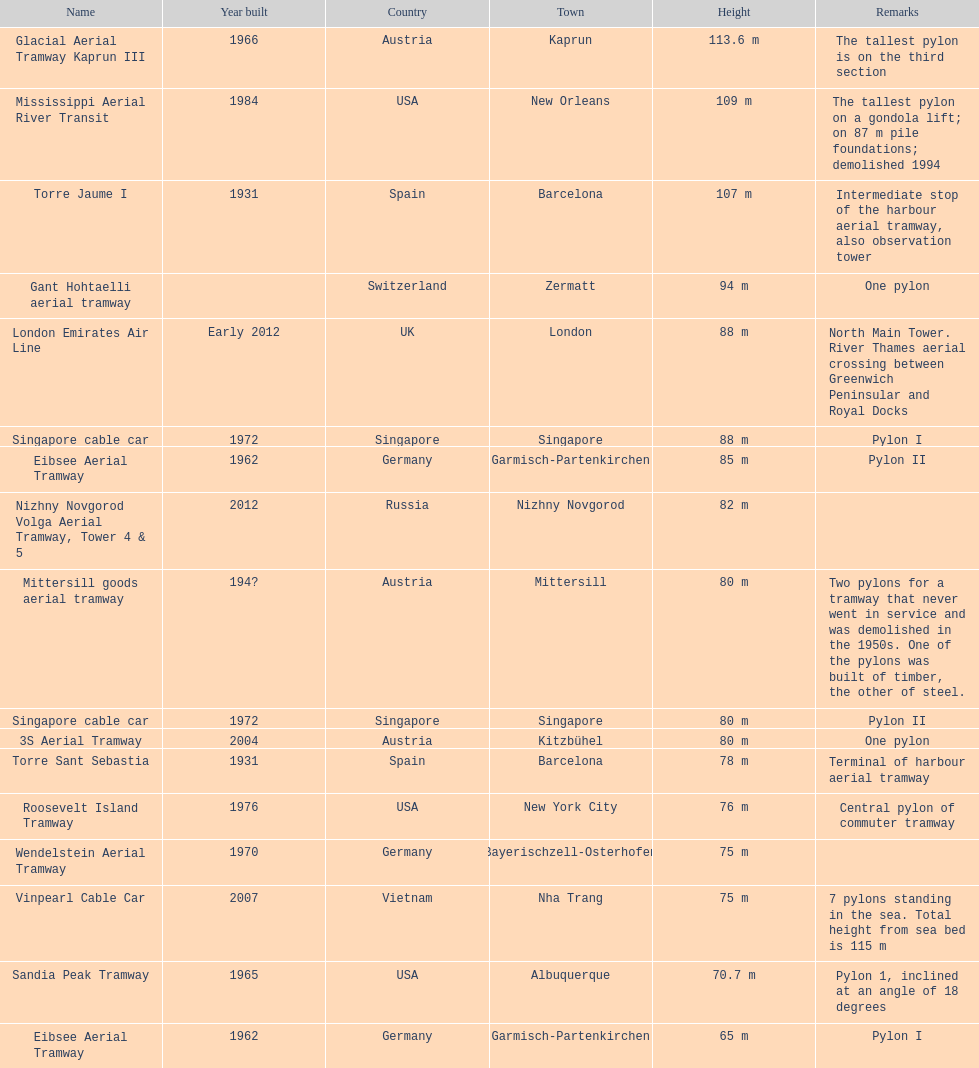The london emirates air line pylon has the same height as which pylon? Singapore cable car. 